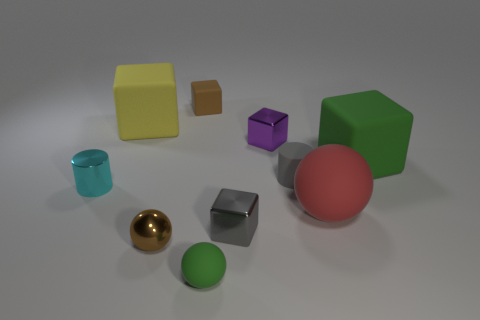Subtract 1 cubes. How many cubes are left? 4 Subtract all gray shiny blocks. How many blocks are left? 4 Subtract all purple cubes. How many cubes are left? 4 Subtract all red blocks. Subtract all gray spheres. How many blocks are left? 5 Subtract all spheres. How many objects are left? 7 Subtract 1 brown spheres. How many objects are left? 9 Subtract all cyan cubes. Subtract all gray cylinders. How many objects are left? 9 Add 6 tiny brown blocks. How many tiny brown blocks are left? 7 Add 2 purple cubes. How many purple cubes exist? 3 